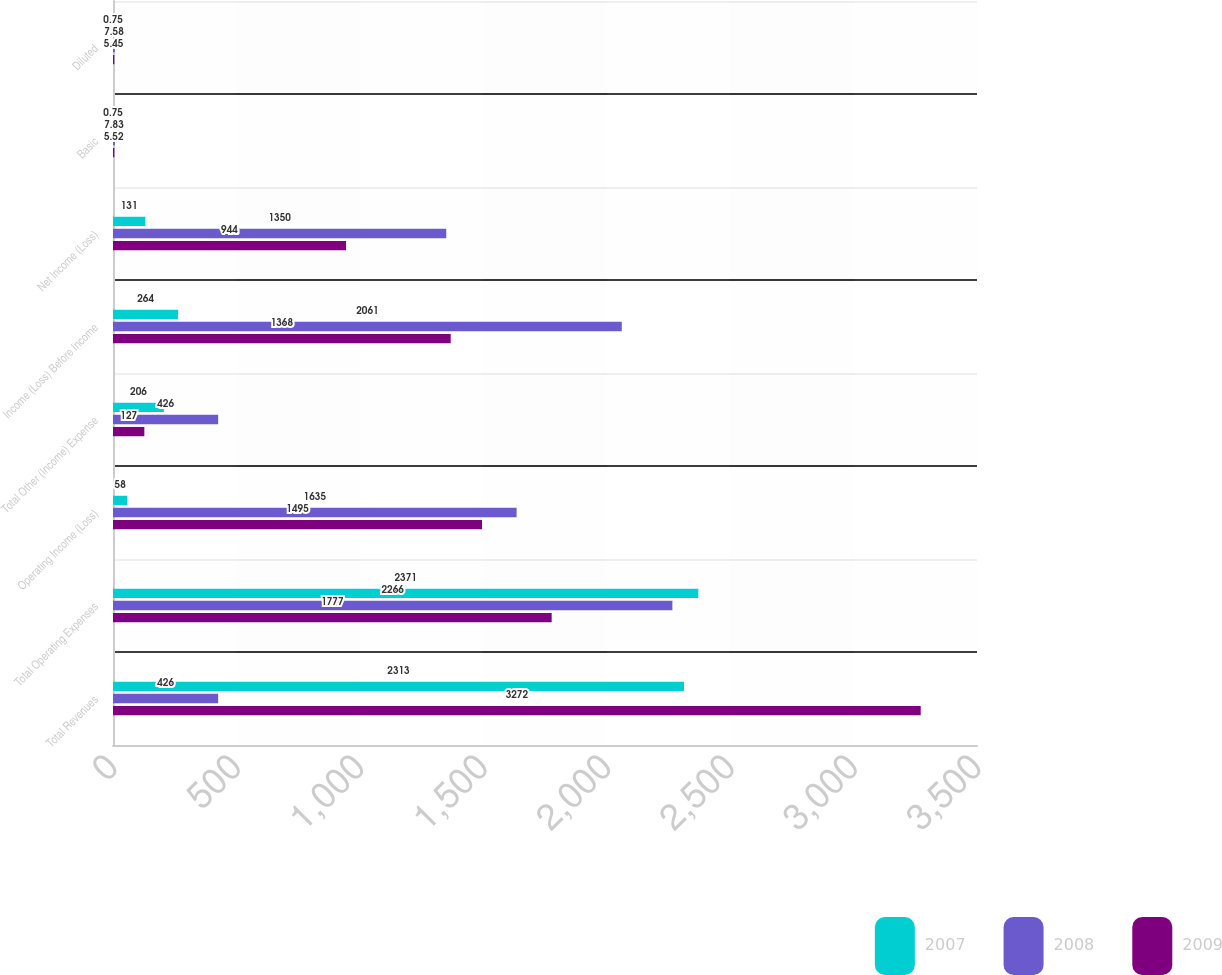Convert chart. <chart><loc_0><loc_0><loc_500><loc_500><stacked_bar_chart><ecel><fcel>Total Revenues<fcel>Total Operating Expenses<fcel>Operating Income (Loss)<fcel>Total Other (Income) Expense<fcel>Income (Loss) Before Income<fcel>Net Income (Loss)<fcel>Basic<fcel>Diluted<nl><fcel>2007<fcel>2313<fcel>2371<fcel>58<fcel>206<fcel>264<fcel>131<fcel>0.75<fcel>0.75<nl><fcel>2008<fcel>426<fcel>2266<fcel>1635<fcel>426<fcel>2061<fcel>1350<fcel>7.83<fcel>7.58<nl><fcel>2009<fcel>3272<fcel>1777<fcel>1495<fcel>127<fcel>1368<fcel>944<fcel>5.52<fcel>5.45<nl></chart> 